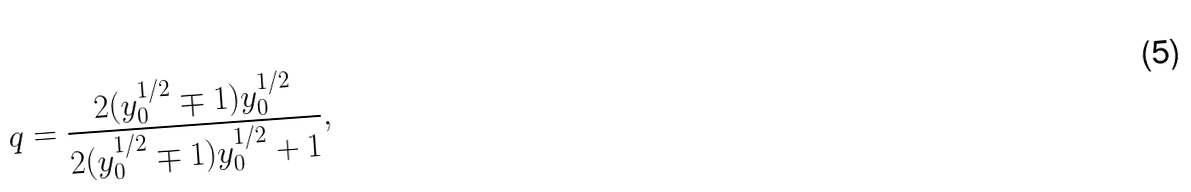<formula> <loc_0><loc_0><loc_500><loc_500>q = \frac { 2 ( y _ { 0 } ^ { 1 / 2 } \mp 1 ) y _ { 0 } ^ { 1 / 2 } } { 2 ( y _ { 0 } ^ { 1 / 2 } \mp 1 ) y _ { 0 } ^ { 1 / 2 } + 1 } ,</formula> 